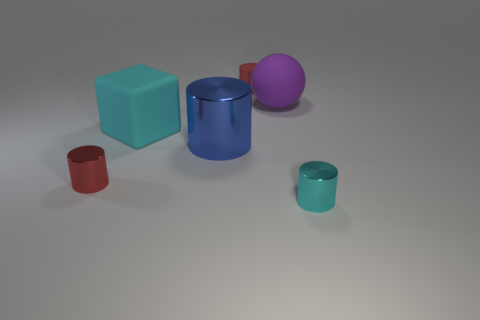Is there a red object of the same shape as the blue object?
Provide a succinct answer. Yes. There is a red object in front of the cyan rubber object; is its shape the same as the tiny red thing that is behind the tiny red metal cylinder?
Your response must be concise. Yes. Are there any blue metal objects of the same size as the cyan block?
Offer a terse response. Yes. Is the number of large spheres that are right of the large purple object the same as the number of objects on the left side of the big cyan block?
Keep it short and to the point. No. Is the material of the red thing that is behind the blue metal cylinder the same as the cyan thing that is on the left side of the purple sphere?
Make the answer very short. Yes. What material is the cyan cube?
Give a very brief answer. Rubber. What number of other things are there of the same color as the rubber block?
Your response must be concise. 1. What number of big blue objects are there?
Keep it short and to the point. 1. There is a big thing on the right side of the small red cylinder behind the red metallic thing; what is its material?
Offer a very short reply. Rubber. There is a cyan cylinder that is the same size as the red metal cylinder; what material is it?
Give a very brief answer. Metal. 